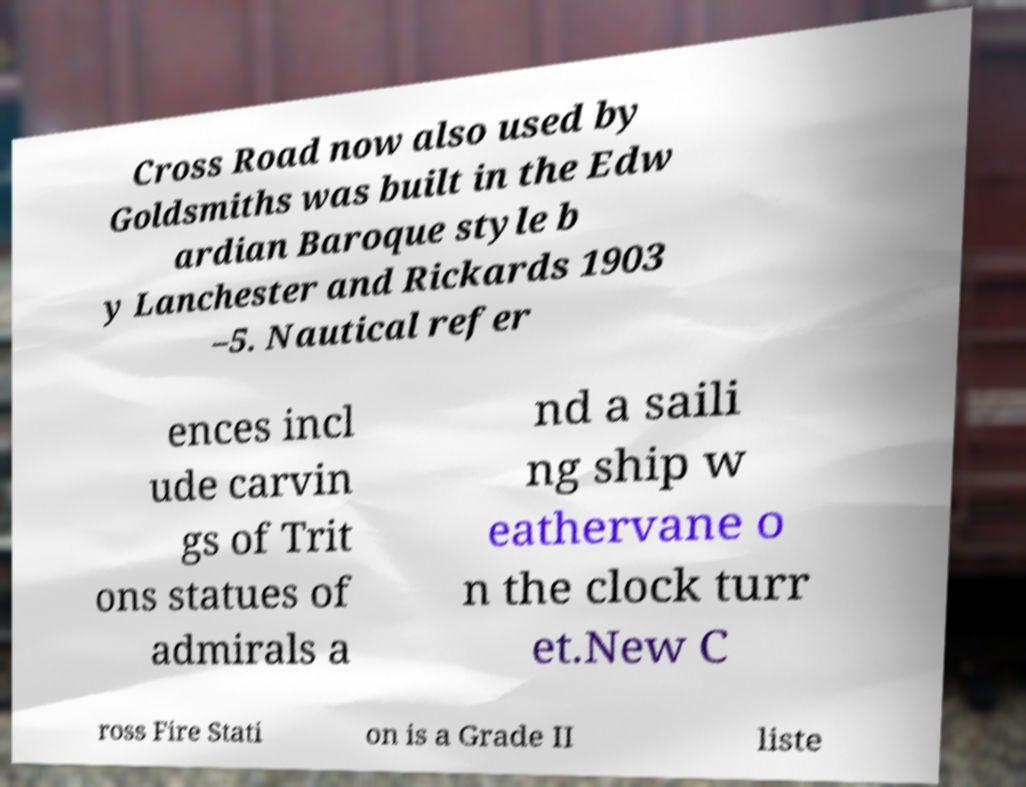For documentation purposes, I need the text within this image transcribed. Could you provide that? Cross Road now also used by Goldsmiths was built in the Edw ardian Baroque style b y Lanchester and Rickards 1903 –5. Nautical refer ences incl ude carvin gs of Trit ons statues of admirals a nd a saili ng ship w eathervane o n the clock turr et.New C ross Fire Stati on is a Grade II liste 